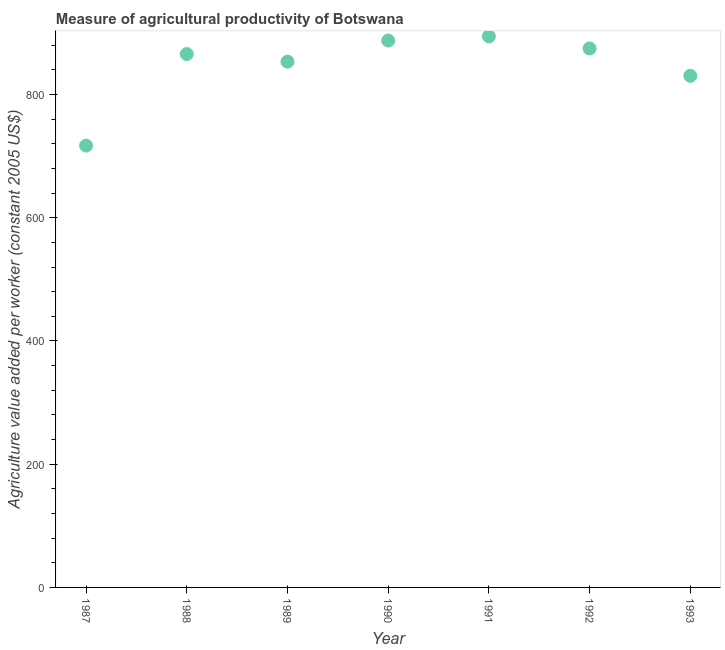What is the agriculture value added per worker in 1992?
Your answer should be very brief. 874.75. Across all years, what is the maximum agriculture value added per worker?
Offer a very short reply. 894.49. Across all years, what is the minimum agriculture value added per worker?
Keep it short and to the point. 717.09. In which year was the agriculture value added per worker maximum?
Your answer should be very brief. 1991. What is the sum of the agriculture value added per worker?
Your answer should be very brief. 5923.27. What is the difference between the agriculture value added per worker in 1989 and 1990?
Provide a succinct answer. -34.24. What is the average agriculture value added per worker per year?
Your response must be concise. 846.18. What is the median agriculture value added per worker?
Provide a succinct answer. 865.65. In how many years, is the agriculture value added per worker greater than 280 US$?
Ensure brevity in your answer.  7. Do a majority of the years between 1993 and 1988 (inclusive) have agriculture value added per worker greater than 40 US$?
Make the answer very short. Yes. What is the ratio of the agriculture value added per worker in 1987 to that in 1991?
Give a very brief answer. 0.8. Is the agriculture value added per worker in 1988 less than that in 1989?
Give a very brief answer. No. What is the difference between the highest and the second highest agriculture value added per worker?
Offer a very short reply. 6.89. Is the sum of the agriculture value added per worker in 1989 and 1992 greater than the maximum agriculture value added per worker across all years?
Your response must be concise. Yes. What is the difference between the highest and the lowest agriculture value added per worker?
Offer a terse response. 177.41. Does the agriculture value added per worker monotonically increase over the years?
Make the answer very short. No. Are the values on the major ticks of Y-axis written in scientific E-notation?
Give a very brief answer. No. Does the graph contain any zero values?
Your answer should be compact. No. What is the title of the graph?
Your answer should be very brief. Measure of agricultural productivity of Botswana. What is the label or title of the X-axis?
Your answer should be very brief. Year. What is the label or title of the Y-axis?
Provide a succinct answer. Agriculture value added per worker (constant 2005 US$). What is the Agriculture value added per worker (constant 2005 US$) in 1987?
Give a very brief answer. 717.09. What is the Agriculture value added per worker (constant 2005 US$) in 1988?
Offer a very short reply. 865.65. What is the Agriculture value added per worker (constant 2005 US$) in 1989?
Make the answer very short. 853.36. What is the Agriculture value added per worker (constant 2005 US$) in 1990?
Your response must be concise. 887.6. What is the Agriculture value added per worker (constant 2005 US$) in 1991?
Offer a very short reply. 894.49. What is the Agriculture value added per worker (constant 2005 US$) in 1992?
Your answer should be compact. 874.75. What is the Agriculture value added per worker (constant 2005 US$) in 1993?
Give a very brief answer. 830.33. What is the difference between the Agriculture value added per worker (constant 2005 US$) in 1987 and 1988?
Offer a terse response. -148.56. What is the difference between the Agriculture value added per worker (constant 2005 US$) in 1987 and 1989?
Ensure brevity in your answer.  -136.27. What is the difference between the Agriculture value added per worker (constant 2005 US$) in 1987 and 1990?
Provide a short and direct response. -170.51. What is the difference between the Agriculture value added per worker (constant 2005 US$) in 1987 and 1991?
Your answer should be very brief. -177.41. What is the difference between the Agriculture value added per worker (constant 2005 US$) in 1987 and 1992?
Offer a very short reply. -157.66. What is the difference between the Agriculture value added per worker (constant 2005 US$) in 1987 and 1993?
Give a very brief answer. -113.25. What is the difference between the Agriculture value added per worker (constant 2005 US$) in 1988 and 1989?
Offer a terse response. 12.29. What is the difference between the Agriculture value added per worker (constant 2005 US$) in 1988 and 1990?
Provide a succinct answer. -21.95. What is the difference between the Agriculture value added per worker (constant 2005 US$) in 1988 and 1991?
Provide a short and direct response. -28.85. What is the difference between the Agriculture value added per worker (constant 2005 US$) in 1988 and 1992?
Keep it short and to the point. -9.1. What is the difference between the Agriculture value added per worker (constant 2005 US$) in 1988 and 1993?
Ensure brevity in your answer.  35.31. What is the difference between the Agriculture value added per worker (constant 2005 US$) in 1989 and 1990?
Your answer should be very brief. -34.24. What is the difference between the Agriculture value added per worker (constant 2005 US$) in 1989 and 1991?
Make the answer very short. -41.14. What is the difference between the Agriculture value added per worker (constant 2005 US$) in 1989 and 1992?
Keep it short and to the point. -21.39. What is the difference between the Agriculture value added per worker (constant 2005 US$) in 1989 and 1993?
Give a very brief answer. 23.02. What is the difference between the Agriculture value added per worker (constant 2005 US$) in 1990 and 1991?
Your response must be concise. -6.89. What is the difference between the Agriculture value added per worker (constant 2005 US$) in 1990 and 1992?
Offer a terse response. 12.85. What is the difference between the Agriculture value added per worker (constant 2005 US$) in 1990 and 1993?
Provide a short and direct response. 57.27. What is the difference between the Agriculture value added per worker (constant 2005 US$) in 1991 and 1992?
Ensure brevity in your answer.  19.75. What is the difference between the Agriculture value added per worker (constant 2005 US$) in 1991 and 1993?
Your response must be concise. 64.16. What is the difference between the Agriculture value added per worker (constant 2005 US$) in 1992 and 1993?
Keep it short and to the point. 44.41. What is the ratio of the Agriculture value added per worker (constant 2005 US$) in 1987 to that in 1988?
Your answer should be very brief. 0.83. What is the ratio of the Agriculture value added per worker (constant 2005 US$) in 1987 to that in 1989?
Keep it short and to the point. 0.84. What is the ratio of the Agriculture value added per worker (constant 2005 US$) in 1987 to that in 1990?
Provide a succinct answer. 0.81. What is the ratio of the Agriculture value added per worker (constant 2005 US$) in 1987 to that in 1991?
Keep it short and to the point. 0.8. What is the ratio of the Agriculture value added per worker (constant 2005 US$) in 1987 to that in 1992?
Give a very brief answer. 0.82. What is the ratio of the Agriculture value added per worker (constant 2005 US$) in 1987 to that in 1993?
Your response must be concise. 0.86. What is the ratio of the Agriculture value added per worker (constant 2005 US$) in 1988 to that in 1989?
Offer a terse response. 1.01. What is the ratio of the Agriculture value added per worker (constant 2005 US$) in 1988 to that in 1993?
Offer a terse response. 1.04. What is the ratio of the Agriculture value added per worker (constant 2005 US$) in 1989 to that in 1990?
Ensure brevity in your answer.  0.96. What is the ratio of the Agriculture value added per worker (constant 2005 US$) in 1989 to that in 1991?
Offer a very short reply. 0.95. What is the ratio of the Agriculture value added per worker (constant 2005 US$) in 1989 to that in 1992?
Provide a short and direct response. 0.98. What is the ratio of the Agriculture value added per worker (constant 2005 US$) in 1989 to that in 1993?
Your answer should be very brief. 1.03. What is the ratio of the Agriculture value added per worker (constant 2005 US$) in 1990 to that in 1992?
Keep it short and to the point. 1.01. What is the ratio of the Agriculture value added per worker (constant 2005 US$) in 1990 to that in 1993?
Give a very brief answer. 1.07. What is the ratio of the Agriculture value added per worker (constant 2005 US$) in 1991 to that in 1992?
Your response must be concise. 1.02. What is the ratio of the Agriculture value added per worker (constant 2005 US$) in 1991 to that in 1993?
Provide a succinct answer. 1.08. What is the ratio of the Agriculture value added per worker (constant 2005 US$) in 1992 to that in 1993?
Provide a succinct answer. 1.05. 